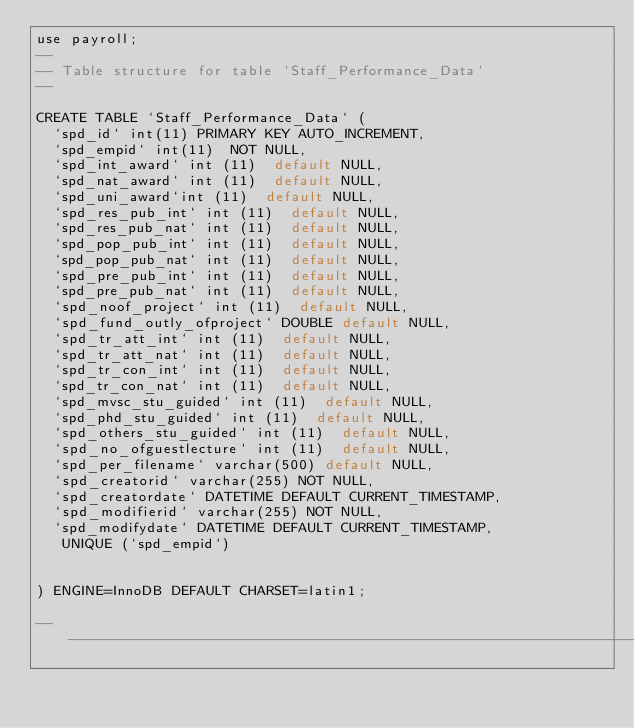Convert code to text. <code><loc_0><loc_0><loc_500><loc_500><_SQL_>use payroll;
--
-- Table structure for table `Staff_Performance_Data`
--

CREATE TABLE `Staff_Performance_Data` (
  `spd_id` int(11) PRIMARY KEY AUTO_INCREMENT,
  `spd_empid` int(11)  NOT NULL,
  `spd_int_award` int (11)  default NULL,
  `spd_nat_award` int (11)  default NULL,
  `spd_uni_award`int (11)  default NULL,
  `spd_res_pub_int` int (11)  default NULL,
  `spd_res_pub_nat` int (11)  default NULL,
  `spd_pop_pub_int` int (11)  default NULL,
  `spd_pop_pub_nat` int (11)  default NULL,
  `spd_pre_pub_int` int (11)  default NULL,
  `spd_pre_pub_nat` int (11)  default NULL,
  `spd_noof_project` int (11)  default NULL,
  `spd_fund_outly_ofproject` DOUBLE default NULL,
  `spd_tr_att_int` int (11)  default NULL,
  `spd_tr_att_nat` int (11)  default NULL,
  `spd_tr_con_int` int (11)  default NULL,
  `spd_tr_con_nat` int (11)  default NULL,
  `spd_mvsc_stu_guided` int (11)  default NULL,
  `spd_phd_stu_guided` int (11)  default NULL,
  `spd_others_stu_guided` int (11)  default NULL,
  `spd_no_ofguestlecture` int (11)  default NULL,
  `spd_per_filename` varchar(500) default NULL,
  `spd_creatorid` varchar(255) NOT NULL, 
  `spd_creatordate` DATETIME DEFAULT CURRENT_TIMESTAMP,
  `spd_modifierid` varchar(255) NOT NULL,
  `spd_modifydate` DATETIME DEFAULT CURRENT_TIMESTAMP, 
   UNIQUE (`spd_empid`)


) ENGINE=InnoDB DEFAULT CHARSET=latin1;

-- -------------------------------------------------------------------
</code> 